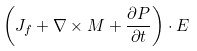Convert formula to latex. <formula><loc_0><loc_0><loc_500><loc_500>\left ( J _ { f } + \nabla \times M + { \frac { \partial P } { \partial t } } \right ) \cdot E</formula> 